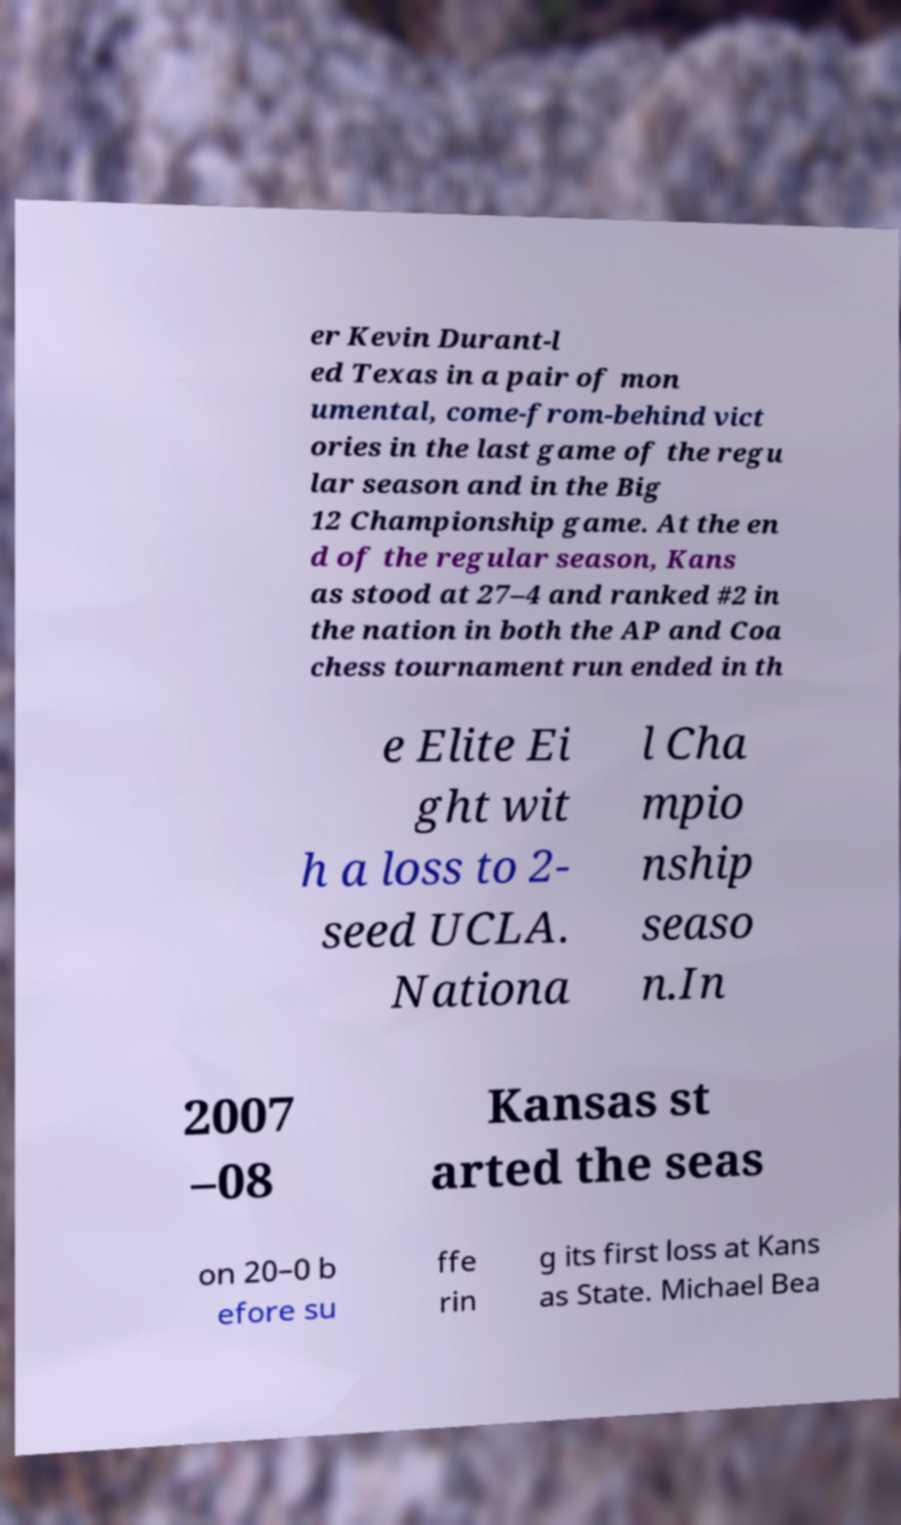Please identify and transcribe the text found in this image. er Kevin Durant-l ed Texas in a pair of mon umental, come-from-behind vict ories in the last game of the regu lar season and in the Big 12 Championship game. At the en d of the regular season, Kans as stood at 27–4 and ranked #2 in the nation in both the AP and Coa chess tournament run ended in th e Elite Ei ght wit h a loss to 2- seed UCLA. Nationa l Cha mpio nship seaso n.In 2007 –08 Kansas st arted the seas on 20–0 b efore su ffe rin g its first loss at Kans as State. Michael Bea 